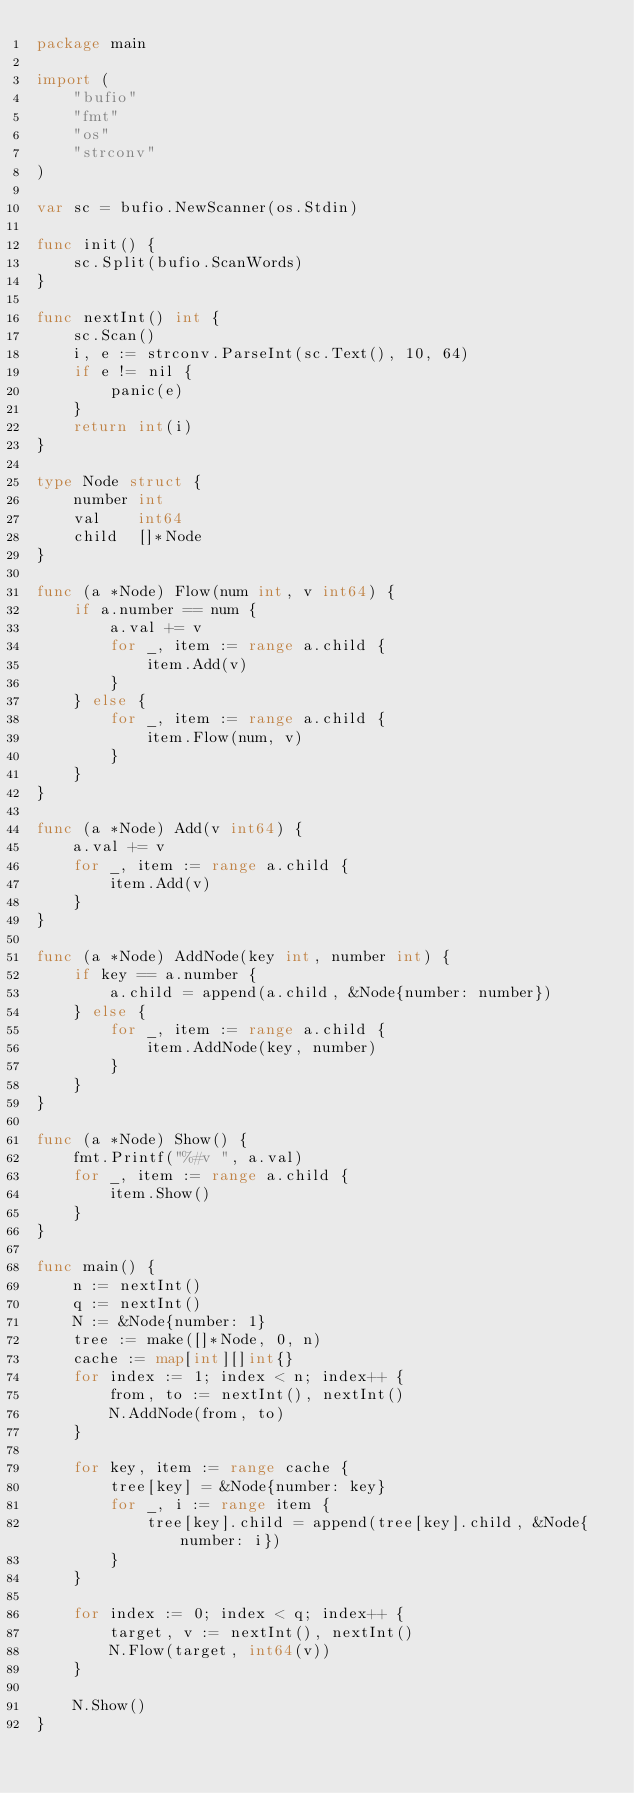<code> <loc_0><loc_0><loc_500><loc_500><_Go_>package main

import (
	"bufio"
	"fmt"
	"os"
	"strconv"
)

var sc = bufio.NewScanner(os.Stdin)

func init() {
	sc.Split(bufio.ScanWords)
}

func nextInt() int {
	sc.Scan()
	i, e := strconv.ParseInt(sc.Text(), 10, 64)
	if e != nil {
		panic(e)
	}
	return int(i)
}

type Node struct {
	number int
	val    int64
	child  []*Node
}

func (a *Node) Flow(num int, v int64) {
	if a.number == num {
		a.val += v
		for _, item := range a.child {
			item.Add(v)
		}
	} else {
		for _, item := range a.child {
			item.Flow(num, v)
		}
	}
}

func (a *Node) Add(v int64) {
	a.val += v
	for _, item := range a.child {
		item.Add(v)
	}
}

func (a *Node) AddNode(key int, number int) {
	if key == a.number {
		a.child = append(a.child, &Node{number: number})
	} else {
		for _, item := range a.child {
			item.AddNode(key, number)
		}
	}
}

func (a *Node) Show() {
	fmt.Printf("%#v ", a.val)
	for _, item := range a.child {
		item.Show()
	}
}

func main() {
	n := nextInt()
	q := nextInt()
	N := &Node{number: 1}
	tree := make([]*Node, 0, n)
	cache := map[int][]int{}
	for index := 1; index < n; index++ {
		from, to := nextInt(), nextInt()
		N.AddNode(from, to)
	}

	for key, item := range cache {
		tree[key] = &Node{number: key}
		for _, i := range item {
			tree[key].child = append(tree[key].child, &Node{number: i})
		}
	}

	for index := 0; index < q; index++ {
		target, v := nextInt(), nextInt()
		N.Flow(target, int64(v))
	}

	N.Show()
}
</code> 